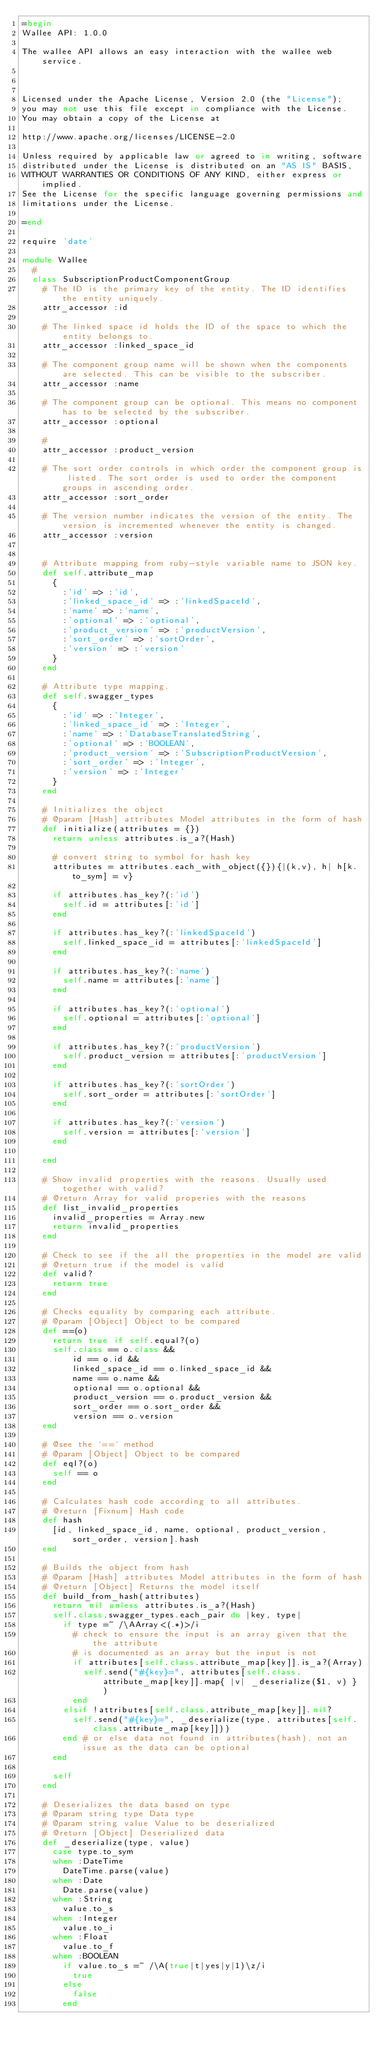Convert code to text. <code><loc_0><loc_0><loc_500><loc_500><_Ruby_>=begin
Wallee API: 1.0.0

The wallee API allows an easy interaction with the wallee web service.



Licensed under the Apache License, Version 2.0 (the "License");
you may not use this file except in compliance with the License.
You may obtain a copy of the License at

http://www.apache.org/licenses/LICENSE-2.0

Unless required by applicable law or agreed to in writing, software
distributed under the License is distributed on an "AS IS" BASIS,
WITHOUT WARRANTIES OR CONDITIONS OF ANY KIND, either express or implied.
See the License for the specific language governing permissions and
limitations under the License.

=end

require 'date'

module Wallee
  # 
  class SubscriptionProductComponentGroup
    # The ID is the primary key of the entity. The ID identifies the entity uniquely.
    attr_accessor :id

    # The linked space id holds the ID of the space to which the entity belongs to.
    attr_accessor :linked_space_id

    # The component group name will be shown when the components are selected. This can be visible to the subscriber.
    attr_accessor :name

    # The component group can be optional. This means no component has to be selected by the subscriber.
    attr_accessor :optional

    # 
    attr_accessor :product_version

    # The sort order controls in which order the component group is listed. The sort order is used to order the component groups in ascending order.
    attr_accessor :sort_order

    # The version number indicates the version of the entity. The version is incremented whenever the entity is changed.
    attr_accessor :version


    # Attribute mapping from ruby-style variable name to JSON key.
    def self.attribute_map
      {
        :'id' => :'id',
        :'linked_space_id' => :'linkedSpaceId',
        :'name' => :'name',
        :'optional' => :'optional',
        :'product_version' => :'productVersion',
        :'sort_order' => :'sortOrder',
        :'version' => :'version'
      }
    end

    # Attribute type mapping.
    def self.swagger_types
      {
        :'id' => :'Integer',
        :'linked_space_id' => :'Integer',
        :'name' => :'DatabaseTranslatedString',
        :'optional' => :'BOOLEAN',
        :'product_version' => :'SubscriptionProductVersion',
        :'sort_order' => :'Integer',
        :'version' => :'Integer'
      }
    end

    # Initializes the object
    # @param [Hash] attributes Model attributes in the form of hash
    def initialize(attributes = {})
      return unless attributes.is_a?(Hash)

      # convert string to symbol for hash key
      attributes = attributes.each_with_object({}){|(k,v), h| h[k.to_sym] = v}

      if attributes.has_key?(:'id')
        self.id = attributes[:'id']
      end

      if attributes.has_key?(:'linkedSpaceId')
        self.linked_space_id = attributes[:'linkedSpaceId']
      end

      if attributes.has_key?(:'name')
        self.name = attributes[:'name']
      end

      if attributes.has_key?(:'optional')
        self.optional = attributes[:'optional']
      end

      if attributes.has_key?(:'productVersion')
        self.product_version = attributes[:'productVersion']
      end

      if attributes.has_key?(:'sortOrder')
        self.sort_order = attributes[:'sortOrder']
      end

      if attributes.has_key?(:'version')
        self.version = attributes[:'version']
      end

    end

    # Show invalid properties with the reasons. Usually used together with valid?
    # @return Array for valid properies with the reasons
    def list_invalid_properties
      invalid_properties = Array.new
      return invalid_properties
    end

    # Check to see if the all the properties in the model are valid
    # @return true if the model is valid
    def valid?
      return true
    end

    # Checks equality by comparing each attribute.
    # @param [Object] Object to be compared
    def ==(o)
      return true if self.equal?(o)
      self.class == o.class &&
          id == o.id &&
          linked_space_id == o.linked_space_id &&
          name == o.name &&
          optional == o.optional &&
          product_version == o.product_version &&
          sort_order == o.sort_order &&
          version == o.version
    end

    # @see the `==` method
    # @param [Object] Object to be compared
    def eql?(o)
      self == o
    end

    # Calculates hash code according to all attributes.
    # @return [Fixnum] Hash code
    def hash
      [id, linked_space_id, name, optional, product_version, sort_order, version].hash
    end

    # Builds the object from hash
    # @param [Hash] attributes Model attributes in the form of hash
    # @return [Object] Returns the model itself
    def build_from_hash(attributes)
      return nil unless attributes.is_a?(Hash)
      self.class.swagger_types.each_pair do |key, type|
        if type =~ /\AArray<(.*)>/i
          # check to ensure the input is an array given that the the attribute
          # is documented as an array but the input is not
          if attributes[self.class.attribute_map[key]].is_a?(Array)
            self.send("#{key}=", attributes[self.class.attribute_map[key]].map{ |v| _deserialize($1, v) } )
          end
        elsif !attributes[self.class.attribute_map[key]].nil?
          self.send("#{key}=", _deserialize(type, attributes[self.class.attribute_map[key]]))
        end # or else data not found in attributes(hash), not an issue as the data can be optional
      end

      self
    end

    # Deserializes the data based on type
    # @param string type Data type
    # @param string value Value to be deserialized
    # @return [Object] Deserialized data
    def _deserialize(type, value)
      case type.to_sym
      when :DateTime
        DateTime.parse(value)
      when :Date
        Date.parse(value)
      when :String
        value.to_s
      when :Integer
        value.to_i
      when :Float
        value.to_f
      when :BOOLEAN
        if value.to_s =~ /\A(true|t|yes|y|1)\z/i
          true
        else
          false
        end</code> 